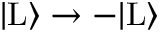<formula> <loc_0><loc_0><loc_500><loc_500>| L \rangle \rightarrow - | L \rangle</formula> 